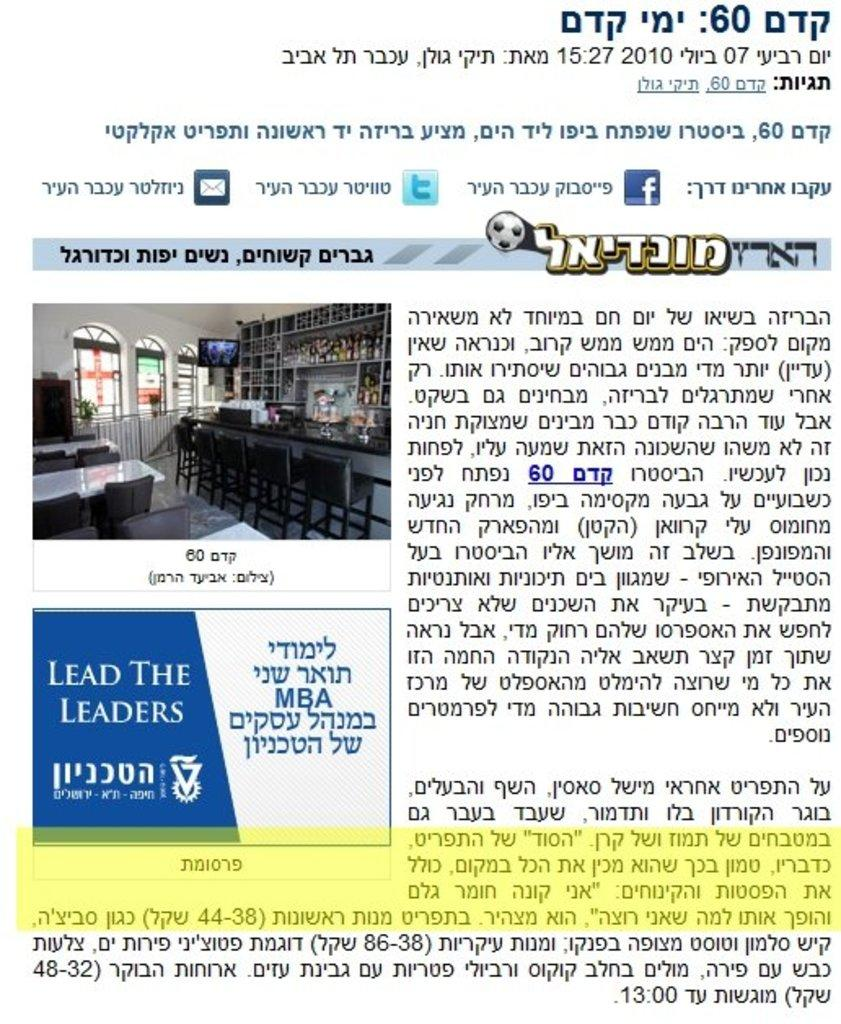Provide a one-sentence caption for the provided image. Poster showing a different language and a blue logo that says Lead The Leaders. 